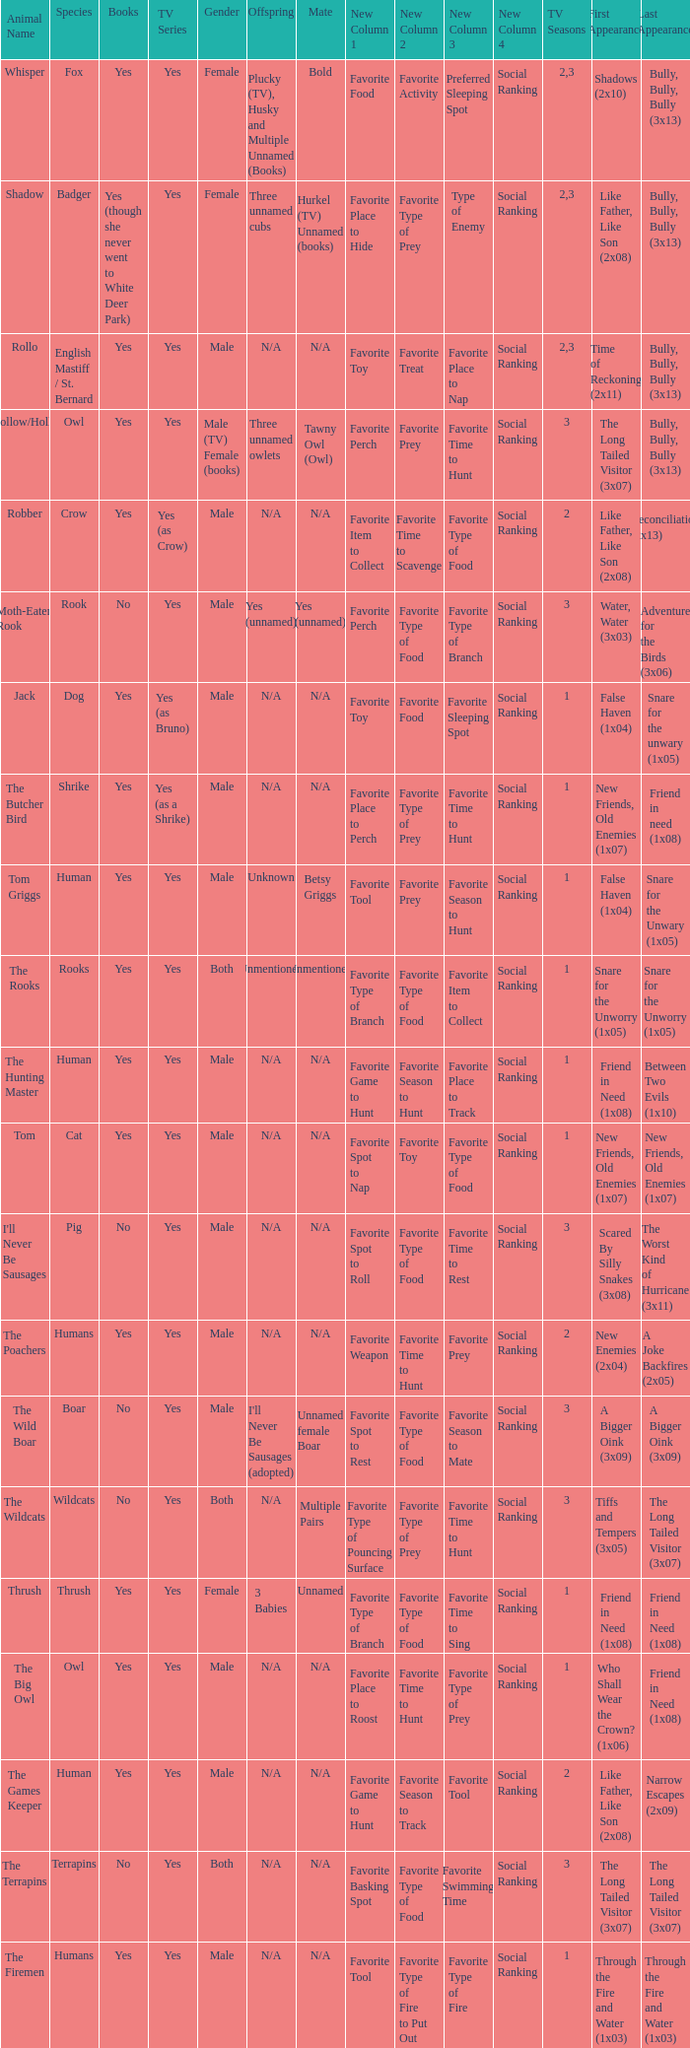What animal was yes for tv series and was a terrapins? The Terrapins. 